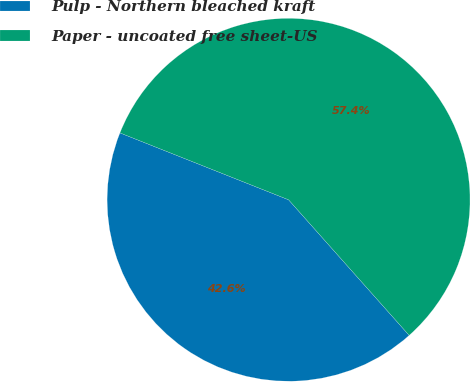Convert chart to OTSL. <chart><loc_0><loc_0><loc_500><loc_500><pie_chart><fcel>Pulp - Northern bleached kraft<fcel>Paper - uncoated free sheet-US<nl><fcel>42.58%<fcel>57.42%<nl></chart> 